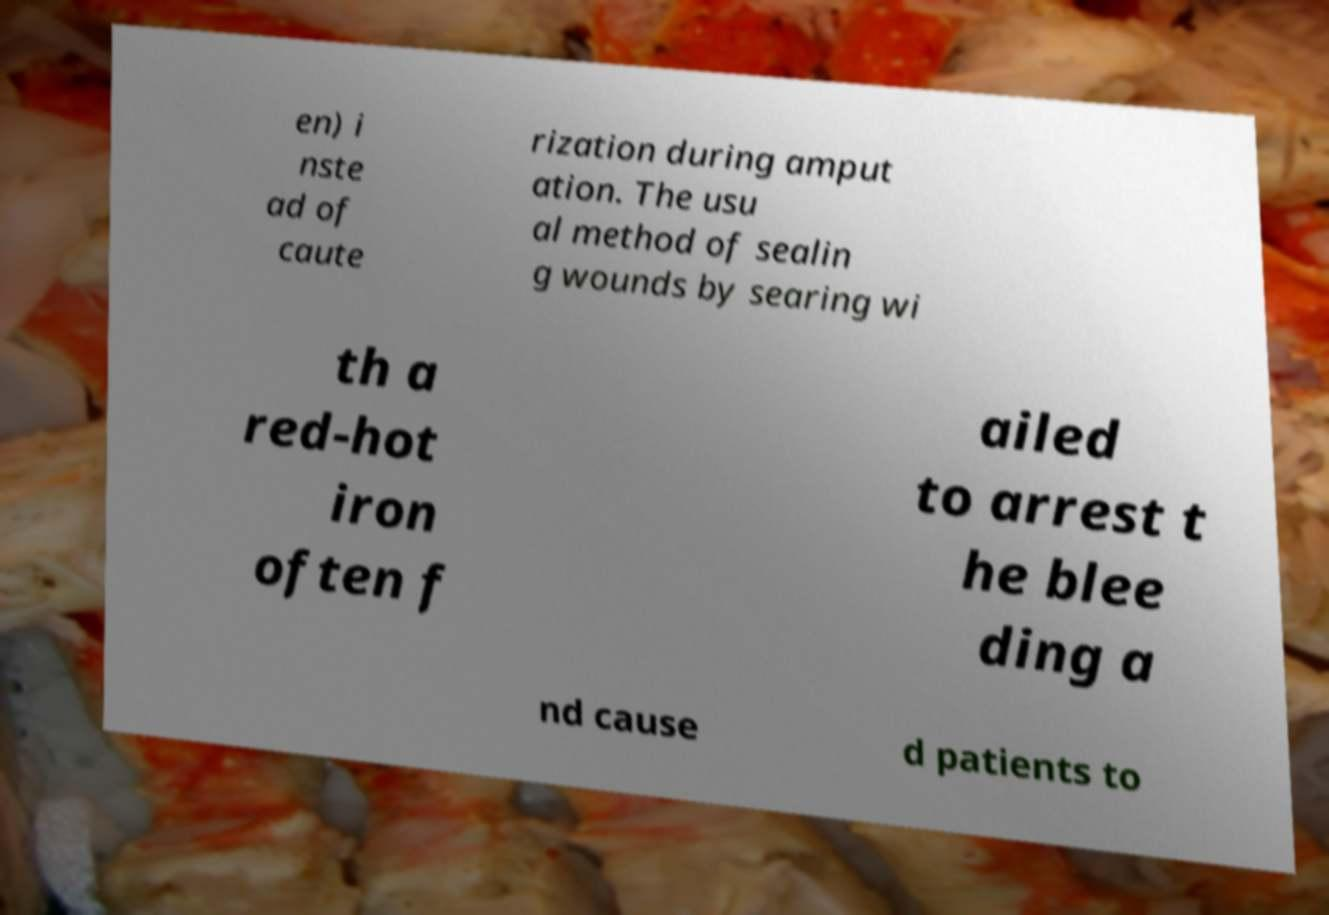Please identify and transcribe the text found in this image. en) i nste ad of caute rization during amput ation. The usu al method of sealin g wounds by searing wi th a red-hot iron often f ailed to arrest t he blee ding a nd cause d patients to 